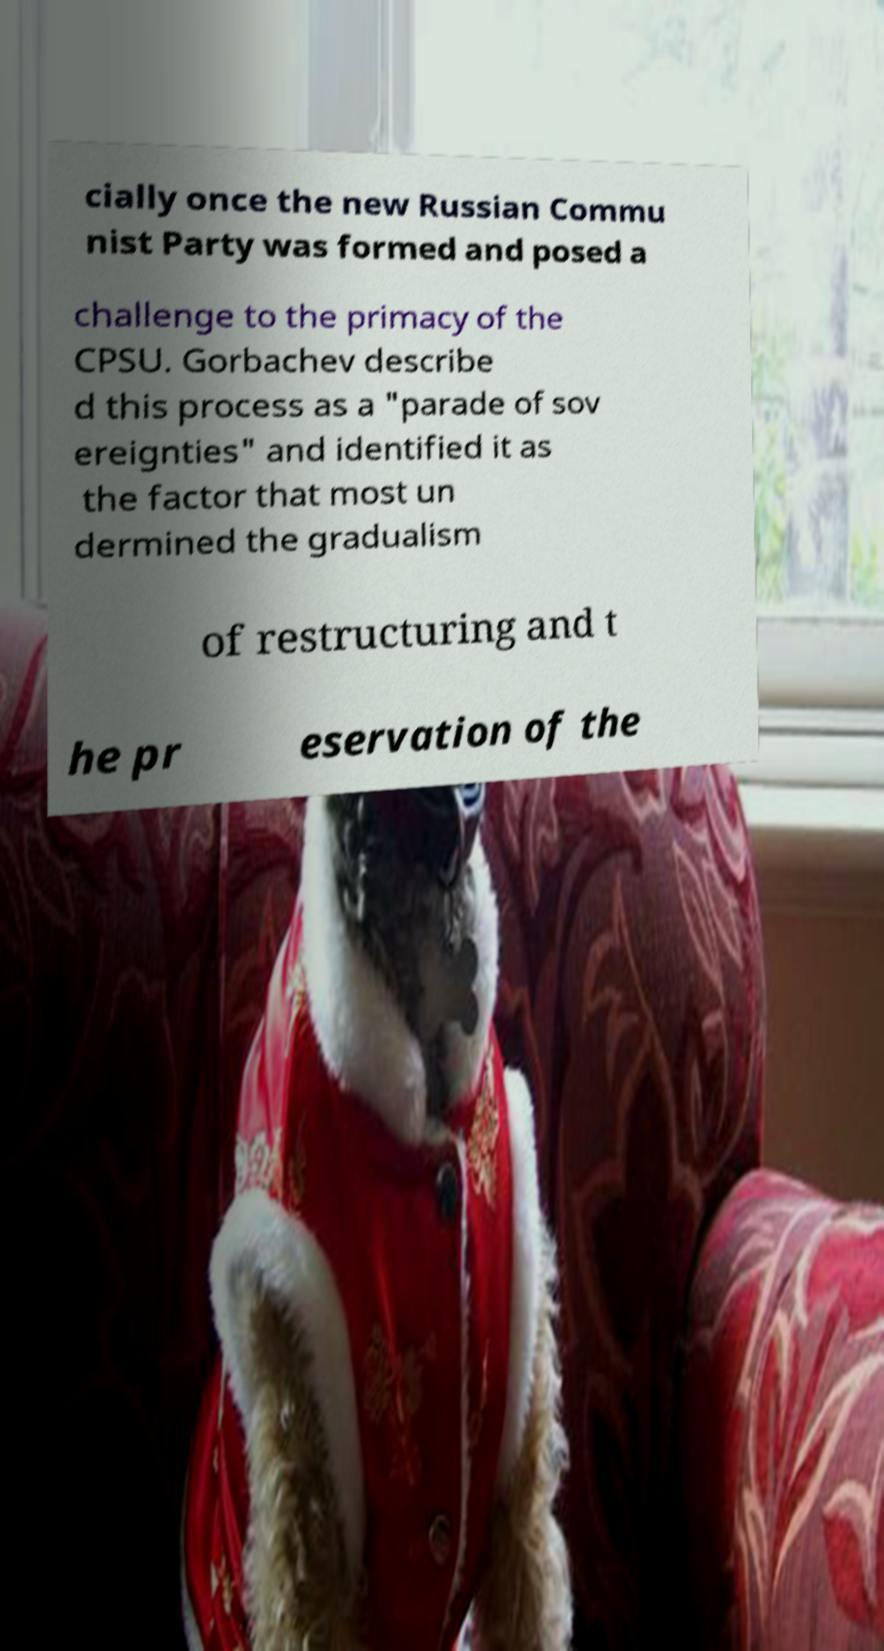I need the written content from this picture converted into text. Can you do that? cially once the new Russian Commu nist Party was formed and posed a challenge to the primacy of the CPSU. Gorbachev describe d this process as a "parade of sov ereignties" and identified it as the factor that most un dermined the gradualism of restructuring and t he pr eservation of the 